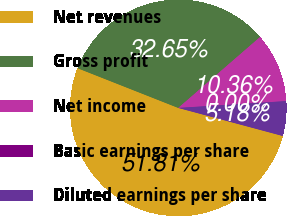Convert chart to OTSL. <chart><loc_0><loc_0><loc_500><loc_500><pie_chart><fcel>Net revenues<fcel>Gross profit<fcel>Net income<fcel>Basic earnings per share<fcel>Diluted earnings per share<nl><fcel>51.81%<fcel>32.65%<fcel>10.36%<fcel>0.0%<fcel>5.18%<nl></chart> 